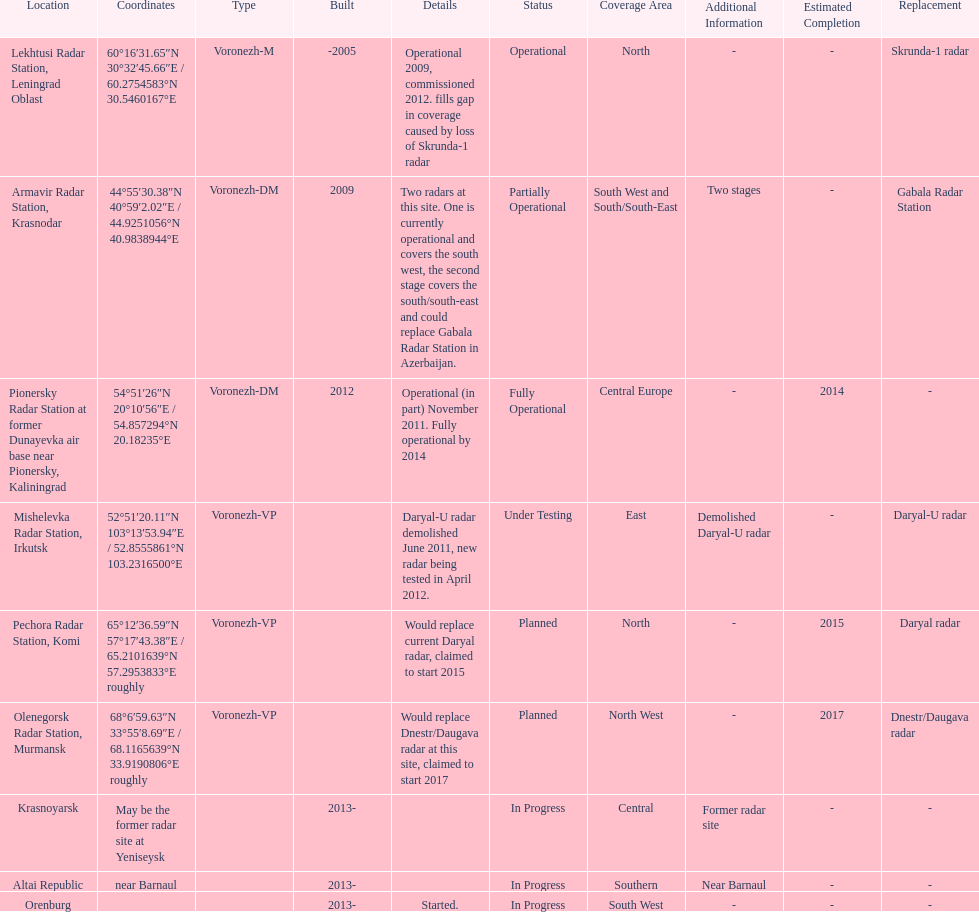Could you help me parse every detail presented in this table? {'header': ['Location', 'Coordinates', 'Type', 'Built', 'Details', 'Status', 'Coverage Area', 'Additional Information', 'Estimated Completion', 'Replacement'], 'rows': [['Lekhtusi Radar Station, Leningrad Oblast', '60°16′31.65″N 30°32′45.66″E\ufeff / \ufeff60.2754583°N 30.5460167°E', 'Voronezh-M', '-2005', 'Operational 2009, commissioned 2012. fills gap in coverage caused by loss of Skrunda-1 radar', 'Operational', 'North', '-', '-', 'Skrunda-1 radar'], ['Armavir Radar Station, Krasnodar', '44°55′30.38″N 40°59′2.02″E\ufeff / \ufeff44.9251056°N 40.9838944°E', 'Voronezh-DM', '2009', 'Two radars at this site. One is currently operational and covers the south west, the second stage covers the south/south-east and could replace Gabala Radar Station in Azerbaijan.', 'Partially Operational', 'South West and South/South-East', 'Two stages', '-', 'Gabala Radar Station'], ['Pionersky Radar Station at former Dunayevka air base near Pionersky, Kaliningrad', '54°51′26″N 20°10′56″E\ufeff / \ufeff54.857294°N 20.18235°E', 'Voronezh-DM', '2012', 'Operational (in part) November 2011. Fully operational by 2014', 'Fully Operational', 'Central Europe', '-', '2014', '-'], ['Mishelevka Radar Station, Irkutsk', '52°51′20.11″N 103°13′53.94″E\ufeff / \ufeff52.8555861°N 103.2316500°E', 'Voronezh-VP', '', 'Daryal-U radar demolished June 2011, new radar being tested in April 2012.', 'Under Testing', 'East', 'Demolished Daryal-U radar', '-', 'Daryal-U radar'], ['Pechora Radar Station, Komi', '65°12′36.59″N 57°17′43.38″E\ufeff / \ufeff65.2101639°N 57.2953833°E roughly', 'Voronezh-VP', '', 'Would replace current Daryal radar, claimed to start 2015', 'Planned', 'North', '-', '2015', 'Daryal radar'], ['Olenegorsk Radar Station, Murmansk', '68°6′59.63″N 33°55′8.69″E\ufeff / \ufeff68.1165639°N 33.9190806°E roughly', 'Voronezh-VP', '', 'Would replace Dnestr/Daugava radar at this site, claimed to start 2017', 'Planned', 'North West', '-', '2017', 'Dnestr/Daugava radar'], ['Krasnoyarsk', 'May be the former radar site at Yeniseysk', '', '2013-', '', 'In Progress', 'Central', 'Former radar site', '-', '-'], ['Altai Republic', 'near Barnaul', '', '2013-', '', 'In Progress', 'Southern', 'Near Barnaul', '-', '-'], ['Orenburg', '', '', '2013-', 'Started.', 'In Progress', 'South West', '-', '-', '-']]} How many voronezh radars were built before 2010? 2. 